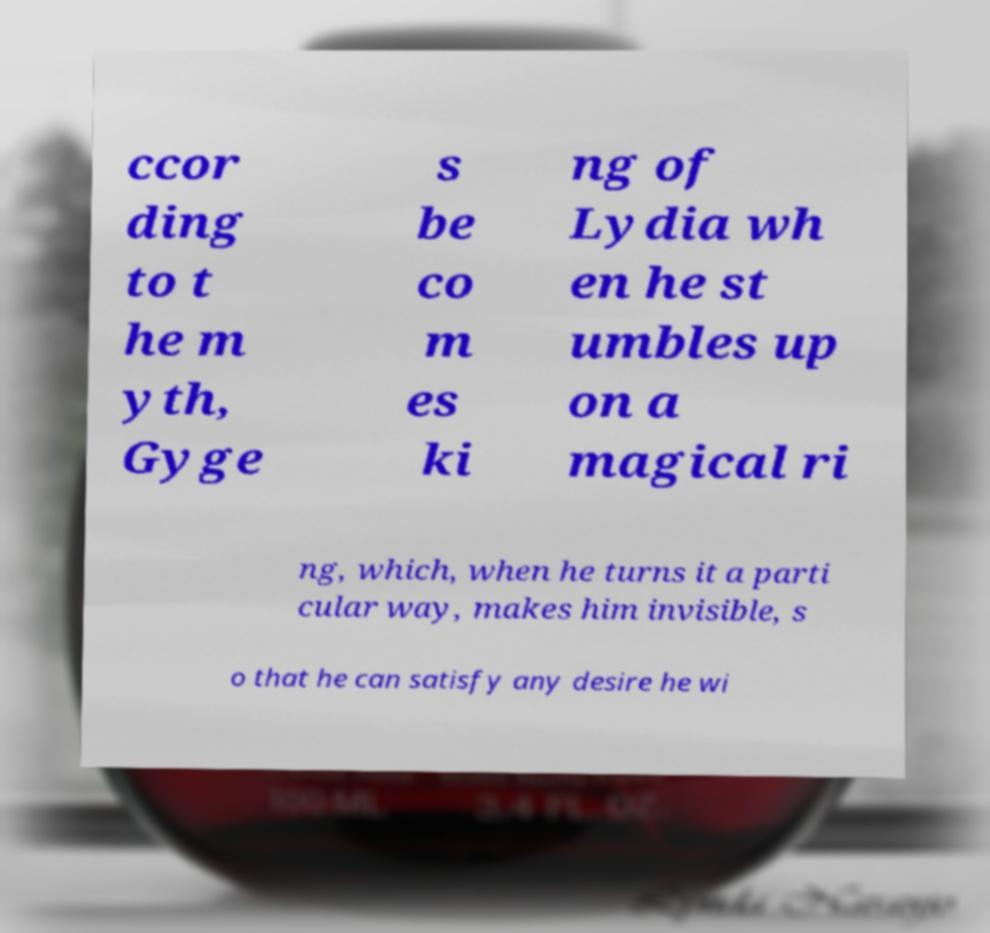There's text embedded in this image that I need extracted. Can you transcribe it verbatim? ccor ding to t he m yth, Gyge s be co m es ki ng of Lydia wh en he st umbles up on a magical ri ng, which, when he turns it a parti cular way, makes him invisible, s o that he can satisfy any desire he wi 